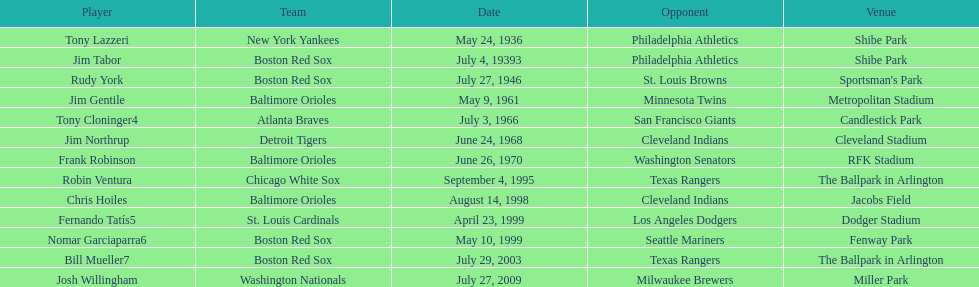On what date did the detroit tigers play the cleveland indians? June 24, 1968. 